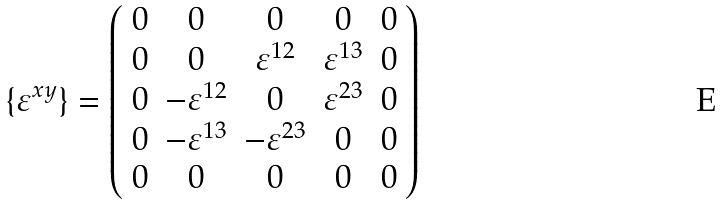<formula> <loc_0><loc_0><loc_500><loc_500>\{ \varepsilon ^ { x y } \} = \left ( \begin{array} { c c c c c } 0 & 0 & 0 & 0 & 0 \\ 0 & 0 & \varepsilon ^ { 1 2 } & \varepsilon ^ { 1 3 } & 0 \\ 0 & - \varepsilon ^ { 1 2 } & 0 & \varepsilon ^ { 2 3 } & 0 \\ 0 & - \varepsilon ^ { 1 3 } & - \varepsilon ^ { 2 3 } & 0 & 0 \\ 0 & 0 & 0 & 0 & 0 \end{array} \right )</formula> 